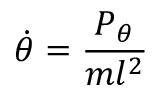<formula> <loc_0><loc_0><loc_500><loc_500>{ \dot { \theta } } = { \frac { P _ { \theta } } { m l ^ { 2 } } }</formula> 